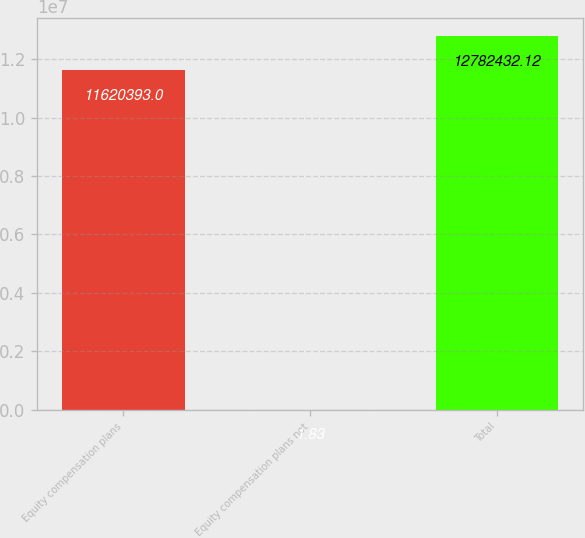Convert chart to OTSL. <chart><loc_0><loc_0><loc_500><loc_500><bar_chart><fcel>Equity compensation plans<fcel>Equity compensation plans not<fcel>Total<nl><fcel>1.16204e+07<fcel>1.83<fcel>1.27824e+07<nl></chart> 